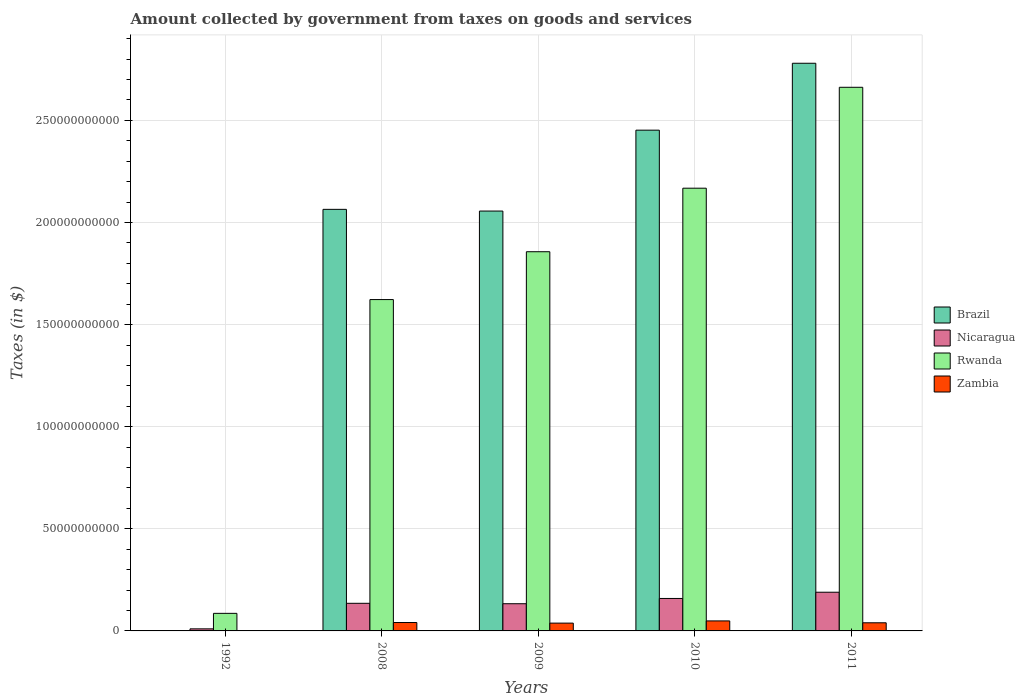Are the number of bars per tick equal to the number of legend labels?
Your response must be concise. Yes. How many bars are there on the 4th tick from the left?
Your response must be concise. 4. How many bars are there on the 5th tick from the right?
Offer a very short reply. 4. What is the label of the 4th group of bars from the left?
Offer a terse response. 2010. In how many cases, is the number of bars for a given year not equal to the number of legend labels?
Provide a succinct answer. 0. What is the amount collected by government from taxes on goods and services in Brazil in 2008?
Keep it short and to the point. 2.06e+11. Across all years, what is the maximum amount collected by government from taxes on goods and services in Rwanda?
Offer a terse response. 2.66e+11. Across all years, what is the minimum amount collected by government from taxes on goods and services in Nicaragua?
Your answer should be very brief. 1.01e+09. In which year was the amount collected by government from taxes on goods and services in Zambia maximum?
Your answer should be very brief. 2010. In which year was the amount collected by government from taxes on goods and services in Nicaragua minimum?
Your response must be concise. 1992. What is the total amount collected by government from taxes on goods and services in Rwanda in the graph?
Make the answer very short. 8.40e+11. What is the difference between the amount collected by government from taxes on goods and services in Brazil in 2008 and that in 2010?
Offer a very short reply. -3.88e+1. What is the difference between the amount collected by government from taxes on goods and services in Zambia in 1992 and the amount collected by government from taxes on goods and services in Nicaragua in 2011?
Your answer should be compact. -1.89e+1. What is the average amount collected by government from taxes on goods and services in Brazil per year?
Your answer should be very brief. 1.87e+11. In the year 2010, what is the difference between the amount collected by government from taxes on goods and services in Nicaragua and amount collected by government from taxes on goods and services in Rwanda?
Your response must be concise. -2.01e+11. What is the ratio of the amount collected by government from taxes on goods and services in Nicaragua in 2009 to that in 2010?
Make the answer very short. 0.84. Is the amount collected by government from taxes on goods and services in Zambia in 2010 less than that in 2011?
Offer a very short reply. No. What is the difference between the highest and the second highest amount collected by government from taxes on goods and services in Brazil?
Keep it short and to the point. 3.28e+1. What is the difference between the highest and the lowest amount collected by government from taxes on goods and services in Brazil?
Provide a succinct answer. 2.78e+11. In how many years, is the amount collected by government from taxes on goods and services in Rwanda greater than the average amount collected by government from taxes on goods and services in Rwanda taken over all years?
Offer a very short reply. 3. Is the sum of the amount collected by government from taxes on goods and services in Zambia in 2010 and 2011 greater than the maximum amount collected by government from taxes on goods and services in Nicaragua across all years?
Keep it short and to the point. No. Is it the case that in every year, the sum of the amount collected by government from taxes on goods and services in Nicaragua and amount collected by government from taxes on goods and services in Brazil is greater than the sum of amount collected by government from taxes on goods and services in Zambia and amount collected by government from taxes on goods and services in Rwanda?
Ensure brevity in your answer.  No. What does the 1st bar from the left in 2011 represents?
Keep it short and to the point. Brazil. Is it the case that in every year, the sum of the amount collected by government from taxes on goods and services in Brazil and amount collected by government from taxes on goods and services in Rwanda is greater than the amount collected by government from taxes on goods and services in Zambia?
Provide a short and direct response. Yes. How many bars are there?
Your answer should be very brief. 20. Does the graph contain any zero values?
Ensure brevity in your answer.  No. Does the graph contain grids?
Give a very brief answer. Yes. How many legend labels are there?
Your response must be concise. 4. What is the title of the graph?
Give a very brief answer. Amount collected by government from taxes on goods and services. Does "Euro area" appear as one of the legend labels in the graph?
Ensure brevity in your answer.  No. What is the label or title of the Y-axis?
Your answer should be compact. Taxes (in $). What is the Taxes (in $) in Brazil in 1992?
Provide a short and direct response. 2.66e+07. What is the Taxes (in $) in Nicaragua in 1992?
Give a very brief answer. 1.01e+09. What is the Taxes (in $) of Rwanda in 1992?
Provide a short and direct response. 8.60e+09. What is the Taxes (in $) in Zambia in 1992?
Offer a very short reply. 4.36e+07. What is the Taxes (in $) in Brazil in 2008?
Offer a very short reply. 2.06e+11. What is the Taxes (in $) in Nicaragua in 2008?
Provide a succinct answer. 1.35e+1. What is the Taxes (in $) of Rwanda in 2008?
Offer a very short reply. 1.62e+11. What is the Taxes (in $) of Zambia in 2008?
Provide a short and direct response. 4.11e+09. What is the Taxes (in $) of Brazil in 2009?
Your answer should be compact. 2.06e+11. What is the Taxes (in $) of Nicaragua in 2009?
Keep it short and to the point. 1.33e+1. What is the Taxes (in $) of Rwanda in 2009?
Your response must be concise. 1.86e+11. What is the Taxes (in $) in Zambia in 2009?
Keep it short and to the point. 3.82e+09. What is the Taxes (in $) of Brazil in 2010?
Offer a terse response. 2.45e+11. What is the Taxes (in $) in Nicaragua in 2010?
Offer a terse response. 1.59e+1. What is the Taxes (in $) in Rwanda in 2010?
Your response must be concise. 2.17e+11. What is the Taxes (in $) in Zambia in 2010?
Your answer should be very brief. 4.90e+09. What is the Taxes (in $) of Brazil in 2011?
Give a very brief answer. 2.78e+11. What is the Taxes (in $) of Nicaragua in 2011?
Offer a terse response. 1.89e+1. What is the Taxes (in $) of Rwanda in 2011?
Provide a succinct answer. 2.66e+11. What is the Taxes (in $) of Zambia in 2011?
Your answer should be compact. 3.98e+09. Across all years, what is the maximum Taxes (in $) of Brazil?
Offer a very short reply. 2.78e+11. Across all years, what is the maximum Taxes (in $) of Nicaragua?
Provide a short and direct response. 1.89e+1. Across all years, what is the maximum Taxes (in $) of Rwanda?
Provide a short and direct response. 2.66e+11. Across all years, what is the maximum Taxes (in $) in Zambia?
Your answer should be compact. 4.90e+09. Across all years, what is the minimum Taxes (in $) in Brazil?
Your answer should be very brief. 2.66e+07. Across all years, what is the minimum Taxes (in $) in Nicaragua?
Your response must be concise. 1.01e+09. Across all years, what is the minimum Taxes (in $) in Rwanda?
Offer a very short reply. 8.60e+09. Across all years, what is the minimum Taxes (in $) of Zambia?
Your answer should be compact. 4.36e+07. What is the total Taxes (in $) in Brazil in the graph?
Your response must be concise. 9.35e+11. What is the total Taxes (in $) in Nicaragua in the graph?
Keep it short and to the point. 6.27e+1. What is the total Taxes (in $) of Rwanda in the graph?
Your answer should be compact. 8.40e+11. What is the total Taxes (in $) in Zambia in the graph?
Offer a very short reply. 1.69e+1. What is the difference between the Taxes (in $) of Brazil in 1992 and that in 2008?
Provide a short and direct response. -2.06e+11. What is the difference between the Taxes (in $) of Nicaragua in 1992 and that in 2008?
Your response must be concise. -1.25e+1. What is the difference between the Taxes (in $) in Rwanda in 1992 and that in 2008?
Your response must be concise. -1.54e+11. What is the difference between the Taxes (in $) in Zambia in 1992 and that in 2008?
Your answer should be compact. -4.07e+09. What is the difference between the Taxes (in $) in Brazil in 1992 and that in 2009?
Ensure brevity in your answer.  -2.06e+11. What is the difference between the Taxes (in $) of Nicaragua in 1992 and that in 2009?
Offer a very short reply. -1.23e+1. What is the difference between the Taxes (in $) of Rwanda in 1992 and that in 2009?
Keep it short and to the point. -1.77e+11. What is the difference between the Taxes (in $) in Zambia in 1992 and that in 2009?
Keep it short and to the point. -3.78e+09. What is the difference between the Taxes (in $) of Brazil in 1992 and that in 2010?
Give a very brief answer. -2.45e+11. What is the difference between the Taxes (in $) of Nicaragua in 1992 and that in 2010?
Provide a succinct answer. -1.49e+1. What is the difference between the Taxes (in $) in Rwanda in 1992 and that in 2010?
Offer a terse response. -2.08e+11. What is the difference between the Taxes (in $) in Zambia in 1992 and that in 2010?
Give a very brief answer. -4.86e+09. What is the difference between the Taxes (in $) in Brazil in 1992 and that in 2011?
Your answer should be very brief. -2.78e+11. What is the difference between the Taxes (in $) in Nicaragua in 1992 and that in 2011?
Provide a short and direct response. -1.79e+1. What is the difference between the Taxes (in $) in Rwanda in 1992 and that in 2011?
Ensure brevity in your answer.  -2.58e+11. What is the difference between the Taxes (in $) in Zambia in 1992 and that in 2011?
Offer a terse response. -3.94e+09. What is the difference between the Taxes (in $) of Brazil in 2008 and that in 2009?
Ensure brevity in your answer.  8.35e+08. What is the difference between the Taxes (in $) in Nicaragua in 2008 and that in 2009?
Make the answer very short. 2.08e+08. What is the difference between the Taxes (in $) in Rwanda in 2008 and that in 2009?
Provide a short and direct response. -2.34e+1. What is the difference between the Taxes (in $) in Zambia in 2008 and that in 2009?
Make the answer very short. 2.91e+08. What is the difference between the Taxes (in $) of Brazil in 2008 and that in 2010?
Your answer should be compact. -3.88e+1. What is the difference between the Taxes (in $) of Nicaragua in 2008 and that in 2010?
Provide a short and direct response. -2.37e+09. What is the difference between the Taxes (in $) of Rwanda in 2008 and that in 2010?
Provide a short and direct response. -5.45e+1. What is the difference between the Taxes (in $) in Zambia in 2008 and that in 2010?
Make the answer very short. -7.88e+08. What is the difference between the Taxes (in $) of Brazil in 2008 and that in 2011?
Ensure brevity in your answer.  -7.15e+1. What is the difference between the Taxes (in $) of Nicaragua in 2008 and that in 2011?
Offer a terse response. -5.42e+09. What is the difference between the Taxes (in $) in Rwanda in 2008 and that in 2011?
Provide a short and direct response. -1.04e+11. What is the difference between the Taxes (in $) in Zambia in 2008 and that in 2011?
Your answer should be compact. 1.33e+08. What is the difference between the Taxes (in $) of Brazil in 2009 and that in 2010?
Your answer should be compact. -3.96e+1. What is the difference between the Taxes (in $) of Nicaragua in 2009 and that in 2010?
Your answer should be compact. -2.58e+09. What is the difference between the Taxes (in $) of Rwanda in 2009 and that in 2010?
Give a very brief answer. -3.11e+1. What is the difference between the Taxes (in $) of Zambia in 2009 and that in 2010?
Provide a succinct answer. -1.08e+09. What is the difference between the Taxes (in $) of Brazil in 2009 and that in 2011?
Provide a succinct answer. -7.24e+1. What is the difference between the Taxes (in $) in Nicaragua in 2009 and that in 2011?
Your answer should be very brief. -5.63e+09. What is the difference between the Taxes (in $) of Rwanda in 2009 and that in 2011?
Give a very brief answer. -8.05e+1. What is the difference between the Taxes (in $) in Zambia in 2009 and that in 2011?
Offer a terse response. -1.58e+08. What is the difference between the Taxes (in $) in Brazil in 2010 and that in 2011?
Give a very brief answer. -3.28e+1. What is the difference between the Taxes (in $) in Nicaragua in 2010 and that in 2011?
Offer a terse response. -3.05e+09. What is the difference between the Taxes (in $) of Rwanda in 2010 and that in 2011?
Provide a short and direct response. -4.94e+1. What is the difference between the Taxes (in $) in Zambia in 2010 and that in 2011?
Ensure brevity in your answer.  9.21e+08. What is the difference between the Taxes (in $) in Brazil in 1992 and the Taxes (in $) in Nicaragua in 2008?
Offer a very short reply. -1.35e+1. What is the difference between the Taxes (in $) of Brazil in 1992 and the Taxes (in $) of Rwanda in 2008?
Provide a succinct answer. -1.62e+11. What is the difference between the Taxes (in $) of Brazil in 1992 and the Taxes (in $) of Zambia in 2008?
Give a very brief answer. -4.09e+09. What is the difference between the Taxes (in $) of Nicaragua in 1992 and the Taxes (in $) of Rwanda in 2008?
Provide a short and direct response. -1.61e+11. What is the difference between the Taxes (in $) of Nicaragua in 1992 and the Taxes (in $) of Zambia in 2008?
Give a very brief answer. -3.10e+09. What is the difference between the Taxes (in $) of Rwanda in 1992 and the Taxes (in $) of Zambia in 2008?
Provide a short and direct response. 4.49e+09. What is the difference between the Taxes (in $) in Brazil in 1992 and the Taxes (in $) in Nicaragua in 2009?
Provide a short and direct response. -1.33e+1. What is the difference between the Taxes (in $) of Brazil in 1992 and the Taxes (in $) of Rwanda in 2009?
Ensure brevity in your answer.  -1.86e+11. What is the difference between the Taxes (in $) in Brazil in 1992 and the Taxes (in $) in Zambia in 2009?
Ensure brevity in your answer.  -3.80e+09. What is the difference between the Taxes (in $) in Nicaragua in 1992 and the Taxes (in $) in Rwanda in 2009?
Your answer should be very brief. -1.85e+11. What is the difference between the Taxes (in $) in Nicaragua in 1992 and the Taxes (in $) in Zambia in 2009?
Offer a very short reply. -2.81e+09. What is the difference between the Taxes (in $) in Rwanda in 1992 and the Taxes (in $) in Zambia in 2009?
Offer a very short reply. 4.78e+09. What is the difference between the Taxes (in $) of Brazil in 1992 and the Taxes (in $) of Nicaragua in 2010?
Offer a very short reply. -1.59e+1. What is the difference between the Taxes (in $) of Brazil in 1992 and the Taxes (in $) of Rwanda in 2010?
Offer a terse response. -2.17e+11. What is the difference between the Taxes (in $) in Brazil in 1992 and the Taxes (in $) in Zambia in 2010?
Your answer should be compact. -4.87e+09. What is the difference between the Taxes (in $) of Nicaragua in 1992 and the Taxes (in $) of Rwanda in 2010?
Keep it short and to the point. -2.16e+11. What is the difference between the Taxes (in $) in Nicaragua in 1992 and the Taxes (in $) in Zambia in 2010?
Provide a short and direct response. -3.89e+09. What is the difference between the Taxes (in $) in Rwanda in 1992 and the Taxes (in $) in Zambia in 2010?
Your answer should be very brief. 3.70e+09. What is the difference between the Taxes (in $) in Brazil in 1992 and the Taxes (in $) in Nicaragua in 2011?
Your response must be concise. -1.89e+1. What is the difference between the Taxes (in $) in Brazil in 1992 and the Taxes (in $) in Rwanda in 2011?
Provide a short and direct response. -2.66e+11. What is the difference between the Taxes (in $) in Brazil in 1992 and the Taxes (in $) in Zambia in 2011?
Make the answer very short. -3.95e+09. What is the difference between the Taxes (in $) of Nicaragua in 1992 and the Taxes (in $) of Rwanda in 2011?
Your answer should be very brief. -2.65e+11. What is the difference between the Taxes (in $) in Nicaragua in 1992 and the Taxes (in $) in Zambia in 2011?
Keep it short and to the point. -2.97e+09. What is the difference between the Taxes (in $) of Rwanda in 1992 and the Taxes (in $) of Zambia in 2011?
Offer a very short reply. 4.62e+09. What is the difference between the Taxes (in $) in Brazil in 2008 and the Taxes (in $) in Nicaragua in 2009?
Your answer should be very brief. 1.93e+11. What is the difference between the Taxes (in $) of Brazil in 2008 and the Taxes (in $) of Rwanda in 2009?
Give a very brief answer. 2.07e+1. What is the difference between the Taxes (in $) in Brazil in 2008 and the Taxes (in $) in Zambia in 2009?
Your answer should be compact. 2.03e+11. What is the difference between the Taxes (in $) of Nicaragua in 2008 and the Taxes (in $) of Rwanda in 2009?
Your response must be concise. -1.72e+11. What is the difference between the Taxes (in $) of Nicaragua in 2008 and the Taxes (in $) of Zambia in 2009?
Give a very brief answer. 9.70e+09. What is the difference between the Taxes (in $) in Rwanda in 2008 and the Taxes (in $) in Zambia in 2009?
Your answer should be very brief. 1.58e+11. What is the difference between the Taxes (in $) in Brazil in 2008 and the Taxes (in $) in Nicaragua in 2010?
Your response must be concise. 1.91e+11. What is the difference between the Taxes (in $) of Brazil in 2008 and the Taxes (in $) of Rwanda in 2010?
Make the answer very short. -1.04e+1. What is the difference between the Taxes (in $) of Brazil in 2008 and the Taxes (in $) of Zambia in 2010?
Offer a very short reply. 2.02e+11. What is the difference between the Taxes (in $) of Nicaragua in 2008 and the Taxes (in $) of Rwanda in 2010?
Offer a terse response. -2.03e+11. What is the difference between the Taxes (in $) in Nicaragua in 2008 and the Taxes (in $) in Zambia in 2010?
Give a very brief answer. 8.62e+09. What is the difference between the Taxes (in $) of Rwanda in 2008 and the Taxes (in $) of Zambia in 2010?
Ensure brevity in your answer.  1.57e+11. What is the difference between the Taxes (in $) in Brazil in 2008 and the Taxes (in $) in Nicaragua in 2011?
Keep it short and to the point. 1.87e+11. What is the difference between the Taxes (in $) of Brazil in 2008 and the Taxes (in $) of Rwanda in 2011?
Your answer should be very brief. -5.98e+1. What is the difference between the Taxes (in $) of Brazil in 2008 and the Taxes (in $) of Zambia in 2011?
Your response must be concise. 2.02e+11. What is the difference between the Taxes (in $) of Nicaragua in 2008 and the Taxes (in $) of Rwanda in 2011?
Make the answer very short. -2.53e+11. What is the difference between the Taxes (in $) in Nicaragua in 2008 and the Taxes (in $) in Zambia in 2011?
Provide a short and direct response. 9.54e+09. What is the difference between the Taxes (in $) of Rwanda in 2008 and the Taxes (in $) of Zambia in 2011?
Your answer should be compact. 1.58e+11. What is the difference between the Taxes (in $) of Brazil in 2009 and the Taxes (in $) of Nicaragua in 2010?
Your answer should be compact. 1.90e+11. What is the difference between the Taxes (in $) in Brazil in 2009 and the Taxes (in $) in Rwanda in 2010?
Offer a terse response. -1.12e+1. What is the difference between the Taxes (in $) of Brazil in 2009 and the Taxes (in $) of Zambia in 2010?
Your answer should be very brief. 2.01e+11. What is the difference between the Taxes (in $) in Nicaragua in 2009 and the Taxes (in $) in Rwanda in 2010?
Your answer should be compact. -2.03e+11. What is the difference between the Taxes (in $) of Nicaragua in 2009 and the Taxes (in $) of Zambia in 2010?
Provide a short and direct response. 8.41e+09. What is the difference between the Taxes (in $) in Rwanda in 2009 and the Taxes (in $) in Zambia in 2010?
Your answer should be compact. 1.81e+11. What is the difference between the Taxes (in $) of Brazil in 2009 and the Taxes (in $) of Nicaragua in 2011?
Make the answer very short. 1.87e+11. What is the difference between the Taxes (in $) in Brazil in 2009 and the Taxes (in $) in Rwanda in 2011?
Ensure brevity in your answer.  -6.06e+1. What is the difference between the Taxes (in $) of Brazil in 2009 and the Taxes (in $) of Zambia in 2011?
Offer a very short reply. 2.02e+11. What is the difference between the Taxes (in $) in Nicaragua in 2009 and the Taxes (in $) in Rwanda in 2011?
Your answer should be very brief. -2.53e+11. What is the difference between the Taxes (in $) in Nicaragua in 2009 and the Taxes (in $) in Zambia in 2011?
Your answer should be compact. 9.34e+09. What is the difference between the Taxes (in $) in Rwanda in 2009 and the Taxes (in $) in Zambia in 2011?
Offer a very short reply. 1.82e+11. What is the difference between the Taxes (in $) of Brazil in 2010 and the Taxes (in $) of Nicaragua in 2011?
Provide a succinct answer. 2.26e+11. What is the difference between the Taxes (in $) in Brazil in 2010 and the Taxes (in $) in Rwanda in 2011?
Provide a short and direct response. -2.10e+1. What is the difference between the Taxes (in $) of Brazil in 2010 and the Taxes (in $) of Zambia in 2011?
Provide a succinct answer. 2.41e+11. What is the difference between the Taxes (in $) in Nicaragua in 2010 and the Taxes (in $) in Rwanda in 2011?
Provide a succinct answer. -2.50e+11. What is the difference between the Taxes (in $) in Nicaragua in 2010 and the Taxes (in $) in Zambia in 2011?
Offer a terse response. 1.19e+1. What is the difference between the Taxes (in $) of Rwanda in 2010 and the Taxes (in $) of Zambia in 2011?
Offer a very short reply. 2.13e+11. What is the average Taxes (in $) in Brazil per year?
Your response must be concise. 1.87e+11. What is the average Taxes (in $) of Nicaragua per year?
Offer a very short reply. 1.25e+1. What is the average Taxes (in $) of Rwanda per year?
Offer a terse response. 1.68e+11. What is the average Taxes (in $) in Zambia per year?
Make the answer very short. 3.37e+09. In the year 1992, what is the difference between the Taxes (in $) of Brazil and Taxes (in $) of Nicaragua?
Ensure brevity in your answer.  -9.87e+08. In the year 1992, what is the difference between the Taxes (in $) of Brazil and Taxes (in $) of Rwanda?
Provide a succinct answer. -8.58e+09. In the year 1992, what is the difference between the Taxes (in $) of Brazil and Taxes (in $) of Zambia?
Keep it short and to the point. -1.70e+07. In the year 1992, what is the difference between the Taxes (in $) of Nicaragua and Taxes (in $) of Rwanda?
Offer a terse response. -7.59e+09. In the year 1992, what is the difference between the Taxes (in $) of Nicaragua and Taxes (in $) of Zambia?
Provide a short and direct response. 9.70e+08. In the year 1992, what is the difference between the Taxes (in $) of Rwanda and Taxes (in $) of Zambia?
Your response must be concise. 8.56e+09. In the year 2008, what is the difference between the Taxes (in $) in Brazil and Taxes (in $) in Nicaragua?
Your response must be concise. 1.93e+11. In the year 2008, what is the difference between the Taxes (in $) in Brazil and Taxes (in $) in Rwanda?
Offer a terse response. 4.42e+1. In the year 2008, what is the difference between the Taxes (in $) of Brazil and Taxes (in $) of Zambia?
Your answer should be compact. 2.02e+11. In the year 2008, what is the difference between the Taxes (in $) of Nicaragua and Taxes (in $) of Rwanda?
Offer a very short reply. -1.49e+11. In the year 2008, what is the difference between the Taxes (in $) in Nicaragua and Taxes (in $) in Zambia?
Your answer should be compact. 9.41e+09. In the year 2008, what is the difference between the Taxes (in $) in Rwanda and Taxes (in $) in Zambia?
Your response must be concise. 1.58e+11. In the year 2009, what is the difference between the Taxes (in $) of Brazil and Taxes (in $) of Nicaragua?
Your response must be concise. 1.92e+11. In the year 2009, what is the difference between the Taxes (in $) in Brazil and Taxes (in $) in Rwanda?
Ensure brevity in your answer.  1.99e+1. In the year 2009, what is the difference between the Taxes (in $) of Brazil and Taxes (in $) of Zambia?
Give a very brief answer. 2.02e+11. In the year 2009, what is the difference between the Taxes (in $) in Nicaragua and Taxes (in $) in Rwanda?
Your answer should be compact. -1.72e+11. In the year 2009, what is the difference between the Taxes (in $) in Nicaragua and Taxes (in $) in Zambia?
Your answer should be compact. 9.49e+09. In the year 2009, what is the difference between the Taxes (in $) in Rwanda and Taxes (in $) in Zambia?
Give a very brief answer. 1.82e+11. In the year 2010, what is the difference between the Taxes (in $) in Brazil and Taxes (in $) in Nicaragua?
Give a very brief answer. 2.29e+11. In the year 2010, what is the difference between the Taxes (in $) of Brazil and Taxes (in $) of Rwanda?
Your answer should be very brief. 2.84e+1. In the year 2010, what is the difference between the Taxes (in $) in Brazil and Taxes (in $) in Zambia?
Offer a terse response. 2.40e+11. In the year 2010, what is the difference between the Taxes (in $) of Nicaragua and Taxes (in $) of Rwanda?
Your answer should be very brief. -2.01e+11. In the year 2010, what is the difference between the Taxes (in $) of Nicaragua and Taxes (in $) of Zambia?
Your answer should be compact. 1.10e+1. In the year 2010, what is the difference between the Taxes (in $) of Rwanda and Taxes (in $) of Zambia?
Make the answer very short. 2.12e+11. In the year 2011, what is the difference between the Taxes (in $) in Brazil and Taxes (in $) in Nicaragua?
Offer a terse response. 2.59e+11. In the year 2011, what is the difference between the Taxes (in $) in Brazil and Taxes (in $) in Rwanda?
Make the answer very short. 1.18e+1. In the year 2011, what is the difference between the Taxes (in $) in Brazil and Taxes (in $) in Zambia?
Your response must be concise. 2.74e+11. In the year 2011, what is the difference between the Taxes (in $) of Nicaragua and Taxes (in $) of Rwanda?
Offer a terse response. -2.47e+11. In the year 2011, what is the difference between the Taxes (in $) in Nicaragua and Taxes (in $) in Zambia?
Provide a short and direct response. 1.50e+1. In the year 2011, what is the difference between the Taxes (in $) of Rwanda and Taxes (in $) of Zambia?
Ensure brevity in your answer.  2.62e+11. What is the ratio of the Taxes (in $) in Nicaragua in 1992 to that in 2008?
Provide a succinct answer. 0.07. What is the ratio of the Taxes (in $) in Rwanda in 1992 to that in 2008?
Keep it short and to the point. 0.05. What is the ratio of the Taxes (in $) in Zambia in 1992 to that in 2008?
Make the answer very short. 0.01. What is the ratio of the Taxes (in $) of Brazil in 1992 to that in 2009?
Give a very brief answer. 0. What is the ratio of the Taxes (in $) of Nicaragua in 1992 to that in 2009?
Keep it short and to the point. 0.08. What is the ratio of the Taxes (in $) of Rwanda in 1992 to that in 2009?
Offer a terse response. 0.05. What is the ratio of the Taxes (in $) in Zambia in 1992 to that in 2009?
Provide a short and direct response. 0.01. What is the ratio of the Taxes (in $) of Nicaragua in 1992 to that in 2010?
Ensure brevity in your answer.  0.06. What is the ratio of the Taxes (in $) in Rwanda in 1992 to that in 2010?
Offer a very short reply. 0.04. What is the ratio of the Taxes (in $) in Zambia in 1992 to that in 2010?
Ensure brevity in your answer.  0.01. What is the ratio of the Taxes (in $) of Nicaragua in 1992 to that in 2011?
Your response must be concise. 0.05. What is the ratio of the Taxes (in $) of Rwanda in 1992 to that in 2011?
Your answer should be very brief. 0.03. What is the ratio of the Taxes (in $) of Zambia in 1992 to that in 2011?
Your answer should be compact. 0.01. What is the ratio of the Taxes (in $) in Nicaragua in 2008 to that in 2009?
Offer a very short reply. 1.02. What is the ratio of the Taxes (in $) of Rwanda in 2008 to that in 2009?
Ensure brevity in your answer.  0.87. What is the ratio of the Taxes (in $) of Zambia in 2008 to that in 2009?
Your answer should be very brief. 1.08. What is the ratio of the Taxes (in $) of Brazil in 2008 to that in 2010?
Make the answer very short. 0.84. What is the ratio of the Taxes (in $) in Nicaragua in 2008 to that in 2010?
Make the answer very short. 0.85. What is the ratio of the Taxes (in $) in Rwanda in 2008 to that in 2010?
Keep it short and to the point. 0.75. What is the ratio of the Taxes (in $) of Zambia in 2008 to that in 2010?
Offer a terse response. 0.84. What is the ratio of the Taxes (in $) of Brazil in 2008 to that in 2011?
Provide a short and direct response. 0.74. What is the ratio of the Taxes (in $) of Nicaragua in 2008 to that in 2011?
Give a very brief answer. 0.71. What is the ratio of the Taxes (in $) of Rwanda in 2008 to that in 2011?
Keep it short and to the point. 0.61. What is the ratio of the Taxes (in $) of Zambia in 2008 to that in 2011?
Provide a short and direct response. 1.03. What is the ratio of the Taxes (in $) in Brazil in 2009 to that in 2010?
Your answer should be very brief. 0.84. What is the ratio of the Taxes (in $) of Nicaragua in 2009 to that in 2010?
Provide a short and direct response. 0.84. What is the ratio of the Taxes (in $) of Rwanda in 2009 to that in 2010?
Make the answer very short. 0.86. What is the ratio of the Taxes (in $) in Zambia in 2009 to that in 2010?
Provide a succinct answer. 0.78. What is the ratio of the Taxes (in $) of Brazil in 2009 to that in 2011?
Ensure brevity in your answer.  0.74. What is the ratio of the Taxes (in $) in Nicaragua in 2009 to that in 2011?
Offer a very short reply. 0.7. What is the ratio of the Taxes (in $) in Rwanda in 2009 to that in 2011?
Make the answer very short. 0.7. What is the ratio of the Taxes (in $) of Zambia in 2009 to that in 2011?
Provide a short and direct response. 0.96. What is the ratio of the Taxes (in $) of Brazil in 2010 to that in 2011?
Give a very brief answer. 0.88. What is the ratio of the Taxes (in $) of Nicaragua in 2010 to that in 2011?
Offer a very short reply. 0.84. What is the ratio of the Taxes (in $) of Rwanda in 2010 to that in 2011?
Offer a terse response. 0.81. What is the ratio of the Taxes (in $) of Zambia in 2010 to that in 2011?
Ensure brevity in your answer.  1.23. What is the difference between the highest and the second highest Taxes (in $) of Brazil?
Keep it short and to the point. 3.28e+1. What is the difference between the highest and the second highest Taxes (in $) of Nicaragua?
Offer a very short reply. 3.05e+09. What is the difference between the highest and the second highest Taxes (in $) of Rwanda?
Offer a very short reply. 4.94e+1. What is the difference between the highest and the second highest Taxes (in $) of Zambia?
Your answer should be compact. 7.88e+08. What is the difference between the highest and the lowest Taxes (in $) of Brazil?
Provide a short and direct response. 2.78e+11. What is the difference between the highest and the lowest Taxes (in $) in Nicaragua?
Ensure brevity in your answer.  1.79e+1. What is the difference between the highest and the lowest Taxes (in $) in Rwanda?
Your answer should be very brief. 2.58e+11. What is the difference between the highest and the lowest Taxes (in $) in Zambia?
Provide a succinct answer. 4.86e+09. 